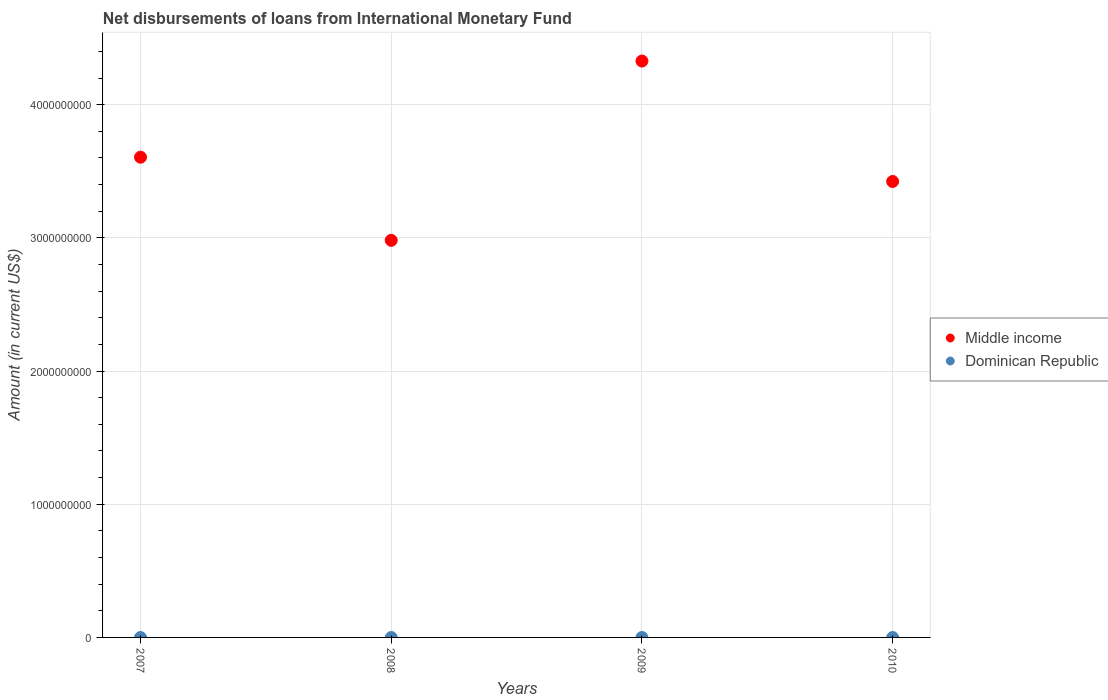Across all years, what is the maximum amount of loans disbursed in Middle income?
Offer a terse response. 4.33e+09. Across all years, what is the minimum amount of loans disbursed in Middle income?
Offer a terse response. 2.98e+09. What is the difference between the amount of loans disbursed in Middle income in 2008 and that in 2009?
Provide a short and direct response. -1.35e+09. What is the difference between the amount of loans disbursed in Middle income in 2010 and the amount of loans disbursed in Dominican Republic in 2008?
Your answer should be compact. 3.42e+09. What is the average amount of loans disbursed in Middle income per year?
Provide a succinct answer. 3.58e+09. What is the ratio of the amount of loans disbursed in Middle income in 2007 to that in 2010?
Your answer should be very brief. 1.05. Is the amount of loans disbursed in Middle income in 2008 less than that in 2010?
Give a very brief answer. Yes. What is the difference between the highest and the second highest amount of loans disbursed in Middle income?
Your answer should be compact. 7.22e+08. Is the sum of the amount of loans disbursed in Middle income in 2008 and 2009 greater than the maximum amount of loans disbursed in Dominican Republic across all years?
Your answer should be compact. Yes. Does the amount of loans disbursed in Dominican Republic monotonically increase over the years?
Offer a terse response. No. Is the amount of loans disbursed in Middle income strictly less than the amount of loans disbursed in Dominican Republic over the years?
Keep it short and to the point. No. How many dotlines are there?
Offer a very short reply. 1. How many years are there in the graph?
Your answer should be very brief. 4. Does the graph contain grids?
Your response must be concise. Yes. How many legend labels are there?
Give a very brief answer. 2. What is the title of the graph?
Ensure brevity in your answer.  Net disbursements of loans from International Monetary Fund. What is the label or title of the X-axis?
Offer a very short reply. Years. What is the Amount (in current US$) in Middle income in 2007?
Make the answer very short. 3.61e+09. What is the Amount (in current US$) in Middle income in 2008?
Your answer should be very brief. 2.98e+09. What is the Amount (in current US$) in Middle income in 2009?
Offer a terse response. 4.33e+09. What is the Amount (in current US$) in Dominican Republic in 2009?
Offer a terse response. 0. What is the Amount (in current US$) in Middle income in 2010?
Keep it short and to the point. 3.42e+09. What is the Amount (in current US$) in Dominican Republic in 2010?
Make the answer very short. 0. Across all years, what is the maximum Amount (in current US$) in Middle income?
Your answer should be compact. 4.33e+09. Across all years, what is the minimum Amount (in current US$) of Middle income?
Offer a very short reply. 2.98e+09. What is the total Amount (in current US$) of Middle income in the graph?
Offer a terse response. 1.43e+1. What is the difference between the Amount (in current US$) in Middle income in 2007 and that in 2008?
Provide a succinct answer. 6.24e+08. What is the difference between the Amount (in current US$) in Middle income in 2007 and that in 2009?
Provide a short and direct response. -7.22e+08. What is the difference between the Amount (in current US$) in Middle income in 2007 and that in 2010?
Make the answer very short. 1.82e+08. What is the difference between the Amount (in current US$) in Middle income in 2008 and that in 2009?
Offer a terse response. -1.35e+09. What is the difference between the Amount (in current US$) in Middle income in 2008 and that in 2010?
Provide a short and direct response. -4.42e+08. What is the difference between the Amount (in current US$) of Middle income in 2009 and that in 2010?
Offer a very short reply. 9.04e+08. What is the average Amount (in current US$) in Middle income per year?
Provide a succinct answer. 3.58e+09. What is the average Amount (in current US$) of Dominican Republic per year?
Give a very brief answer. 0. What is the ratio of the Amount (in current US$) of Middle income in 2007 to that in 2008?
Keep it short and to the point. 1.21. What is the ratio of the Amount (in current US$) of Middle income in 2007 to that in 2009?
Your response must be concise. 0.83. What is the ratio of the Amount (in current US$) in Middle income in 2007 to that in 2010?
Ensure brevity in your answer.  1.05. What is the ratio of the Amount (in current US$) of Middle income in 2008 to that in 2009?
Give a very brief answer. 0.69. What is the ratio of the Amount (in current US$) of Middle income in 2008 to that in 2010?
Offer a very short reply. 0.87. What is the ratio of the Amount (in current US$) of Middle income in 2009 to that in 2010?
Ensure brevity in your answer.  1.26. What is the difference between the highest and the second highest Amount (in current US$) in Middle income?
Provide a short and direct response. 7.22e+08. What is the difference between the highest and the lowest Amount (in current US$) in Middle income?
Make the answer very short. 1.35e+09. 